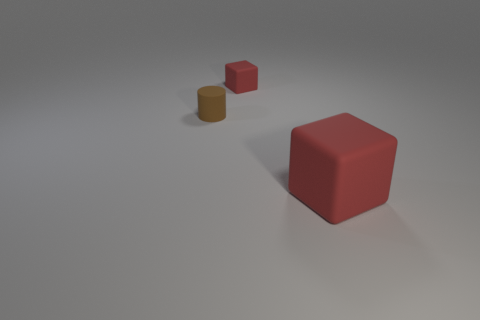Subtract 0 purple spheres. How many objects are left? 3 Subtract all cylinders. How many objects are left? 2 Subtract 1 blocks. How many blocks are left? 1 Subtract all gray blocks. Subtract all green cylinders. How many blocks are left? 2 Subtract all green cylinders. How many purple blocks are left? 0 Subtract all small blocks. Subtract all tiny brown matte things. How many objects are left? 1 Add 3 cubes. How many cubes are left? 5 Add 2 tiny red cylinders. How many tiny red cylinders exist? 2 Add 3 big yellow shiny objects. How many objects exist? 6 